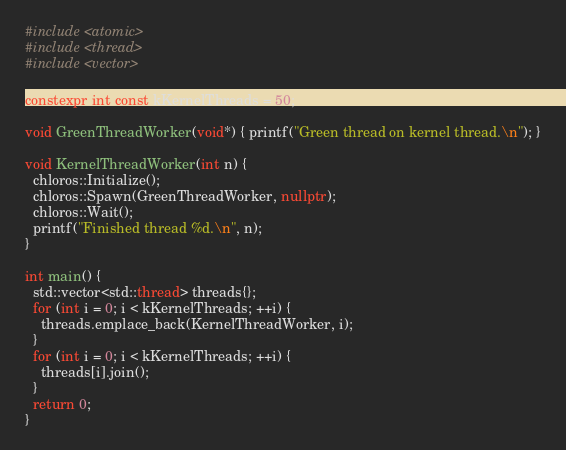Convert code to text. <code><loc_0><loc_0><loc_500><loc_500><_C++_>#include <atomic>
#include <thread>
#include <vector>

constexpr int const kKernelThreads = 50;

void GreenThreadWorker(void*) { printf("Green thread on kernel thread.\n"); }

void KernelThreadWorker(int n) {
  chloros::Initialize();
  chloros::Spawn(GreenThreadWorker, nullptr);
  chloros::Wait();
  printf("Finished thread %d.\n", n);
}

int main() {
  std::vector<std::thread> threads{};
  for (int i = 0; i < kKernelThreads; ++i) {
    threads.emplace_back(KernelThreadWorker, i);
  }
  for (int i = 0; i < kKernelThreads; ++i) {
    threads[i].join();
  }
  return 0;
}
</code> 